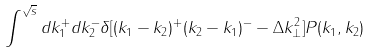<formula> <loc_0><loc_0><loc_500><loc_500>\int ^ { \sqrt { s } } d k _ { 1 } ^ { + } d k _ { 2 } ^ { - } \delta [ ( k _ { 1 } - k _ { 2 } ) ^ { + } ( k _ { 2 } - k _ { 1 } ) ^ { - } - \Delta k _ { \bot } ^ { 2 } ] P ( k _ { 1 } , k _ { 2 } )</formula> 